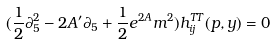Convert formula to latex. <formula><loc_0><loc_0><loc_500><loc_500>( \frac { 1 } { 2 } \partial _ { 5 } ^ { 2 } - 2 A ^ { \prime } \partial _ { 5 } + \frac { 1 } { 2 } e ^ { 2 A } m ^ { 2 } ) h _ { i j } ^ { T T } ( p , y ) = 0</formula> 